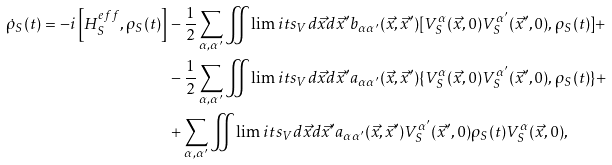<formula> <loc_0><loc_0><loc_500><loc_500>\dot { \rho } _ { S } ( t ) = - i \left [ H _ { S } ^ { e f f } , \rho _ { S } ( t ) \right ] & - \frac { 1 } { 2 } \sum _ { \alpha , \alpha ^ { \prime } } \iint \lim i t s _ { V } d \vec { x } d \vec { x } ^ { \prime } b _ { \alpha \alpha ^ { \prime } } ( \vec { x } , \vec { x } ^ { \prime } ) [ V _ { S } ^ { \alpha } ( \vec { x } , 0 ) V _ { S } ^ { \alpha ^ { \prime } } ( \vec { x } ^ { \prime } , 0 ) , \rho _ { S } ( t ) ] + \\ & - \frac { 1 } { 2 } \sum _ { \alpha , \alpha ^ { \prime } } \iint \lim i t s _ { V } d \vec { x } d \vec { x } ^ { \prime } a _ { \alpha \alpha ^ { \prime } } ( \vec { x } , \vec { x } ^ { \prime } ) \{ V _ { S } ^ { \alpha } ( \vec { x } , 0 ) V _ { S } ^ { \alpha ^ { \prime } } ( \vec { x } ^ { \prime } , 0 ) , \rho _ { S } ( t ) \} + \\ & + \sum _ { \alpha , \alpha ^ { \prime } } \iint \lim i t s _ { V } d \vec { x } d \vec { x } ^ { \prime } a _ { \alpha \alpha ^ { \prime } } ( \vec { x } , \vec { x } ^ { \prime } ) V _ { S } ^ { \alpha ^ { \prime } } ( \vec { x } ^ { \prime } , 0 ) \rho _ { S } ( t ) V _ { S } ^ { \alpha } ( \vec { x } , 0 ) ,</formula> 